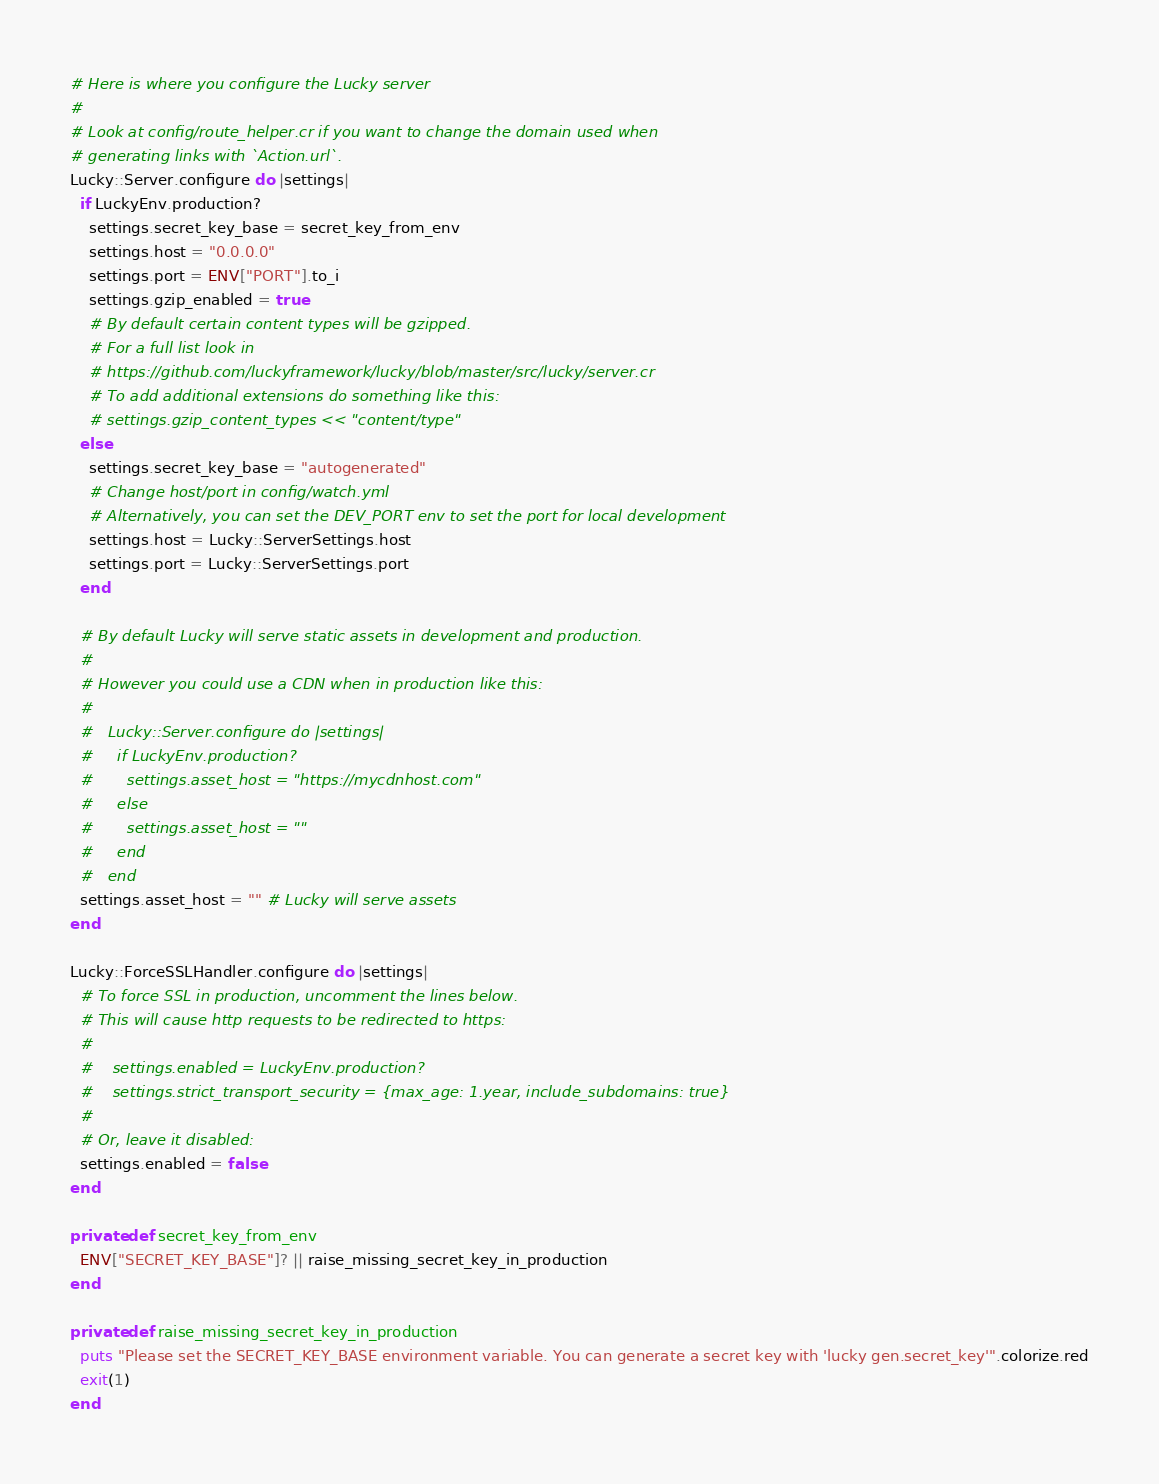Convert code to text. <code><loc_0><loc_0><loc_500><loc_500><_Crystal_># Here is where you configure the Lucky server
#
# Look at config/route_helper.cr if you want to change the domain used when
# generating links with `Action.url`.
Lucky::Server.configure do |settings|
  if LuckyEnv.production?
    settings.secret_key_base = secret_key_from_env
    settings.host = "0.0.0.0"
    settings.port = ENV["PORT"].to_i
    settings.gzip_enabled = true
    # By default certain content types will be gzipped.
    # For a full list look in
    # https://github.com/luckyframework/lucky/blob/master/src/lucky/server.cr
    # To add additional extensions do something like this:
    # settings.gzip_content_types << "content/type"
  else
    settings.secret_key_base = "autogenerated"
    # Change host/port in config/watch.yml
    # Alternatively, you can set the DEV_PORT env to set the port for local development
    settings.host = Lucky::ServerSettings.host
    settings.port = Lucky::ServerSettings.port
  end

  # By default Lucky will serve static assets in development and production.
  #
  # However you could use a CDN when in production like this:
  #
  #   Lucky::Server.configure do |settings|
  #     if LuckyEnv.production?
  #       settings.asset_host = "https://mycdnhost.com"
  #     else
  #       settings.asset_host = ""
  #     end
  #   end
  settings.asset_host = "" # Lucky will serve assets
end

Lucky::ForceSSLHandler.configure do |settings|
  # To force SSL in production, uncomment the lines below.
  # This will cause http requests to be redirected to https:
  #
  #    settings.enabled = LuckyEnv.production?
  #    settings.strict_transport_security = {max_age: 1.year, include_subdomains: true}
  #
  # Or, leave it disabled:
  settings.enabled = false
end

private def secret_key_from_env
  ENV["SECRET_KEY_BASE"]? || raise_missing_secret_key_in_production
end

private def raise_missing_secret_key_in_production
  puts "Please set the SECRET_KEY_BASE environment variable. You can generate a secret key with 'lucky gen.secret_key'".colorize.red
  exit(1)
end
</code> 